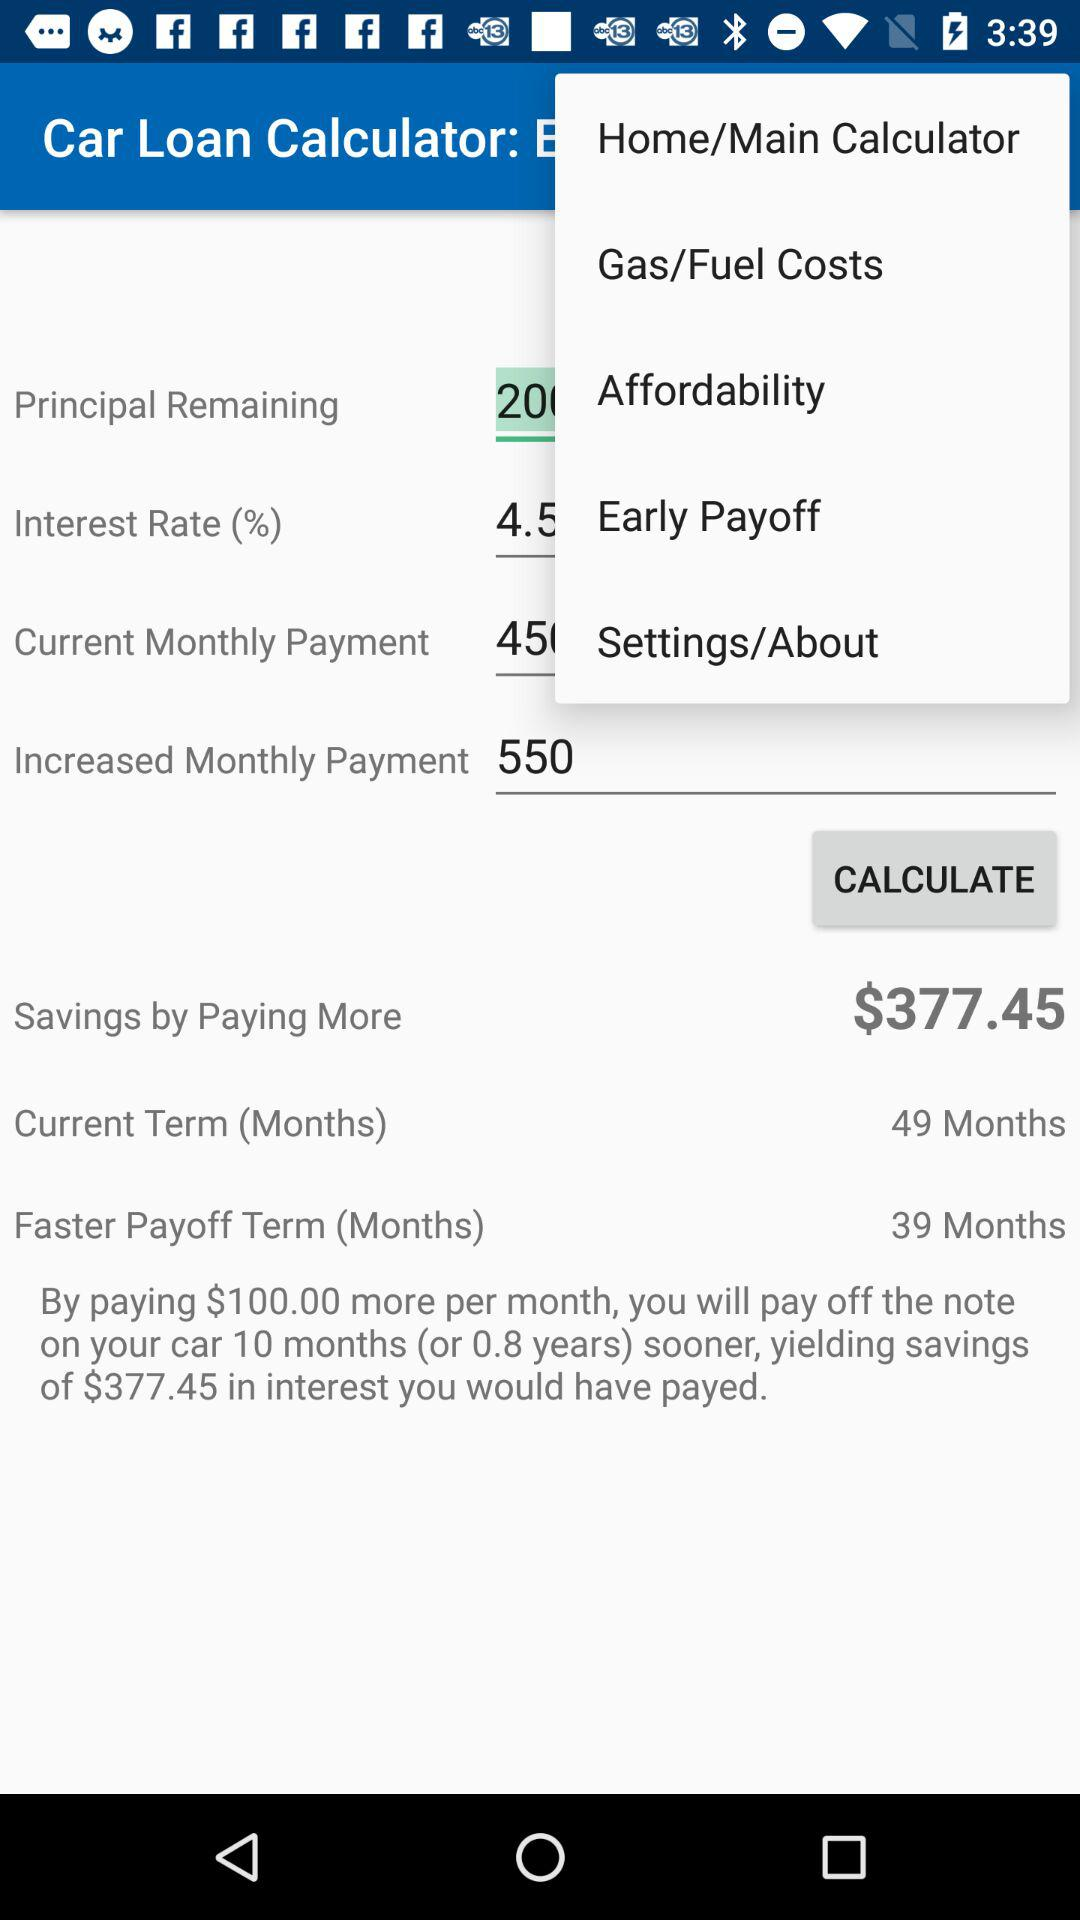How much is the "Faster Payoff Term (Months)"? The "Faster Payoff Term" is 39 months. 